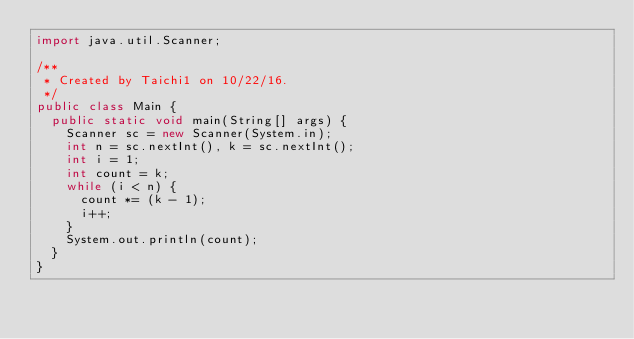Convert code to text. <code><loc_0><loc_0><loc_500><loc_500><_Java_>import java.util.Scanner;

/**
 * Created by Taichi1 on 10/22/16.
 */
public class Main {
	public static void main(String[] args) {
		Scanner sc = new Scanner(System.in);
		int n = sc.nextInt(), k = sc.nextInt();
		int i = 1;
		int count = k;
		while (i < n) {
			count *= (k - 1);
			i++;
		}
		System.out.println(count);
	}
}
</code> 